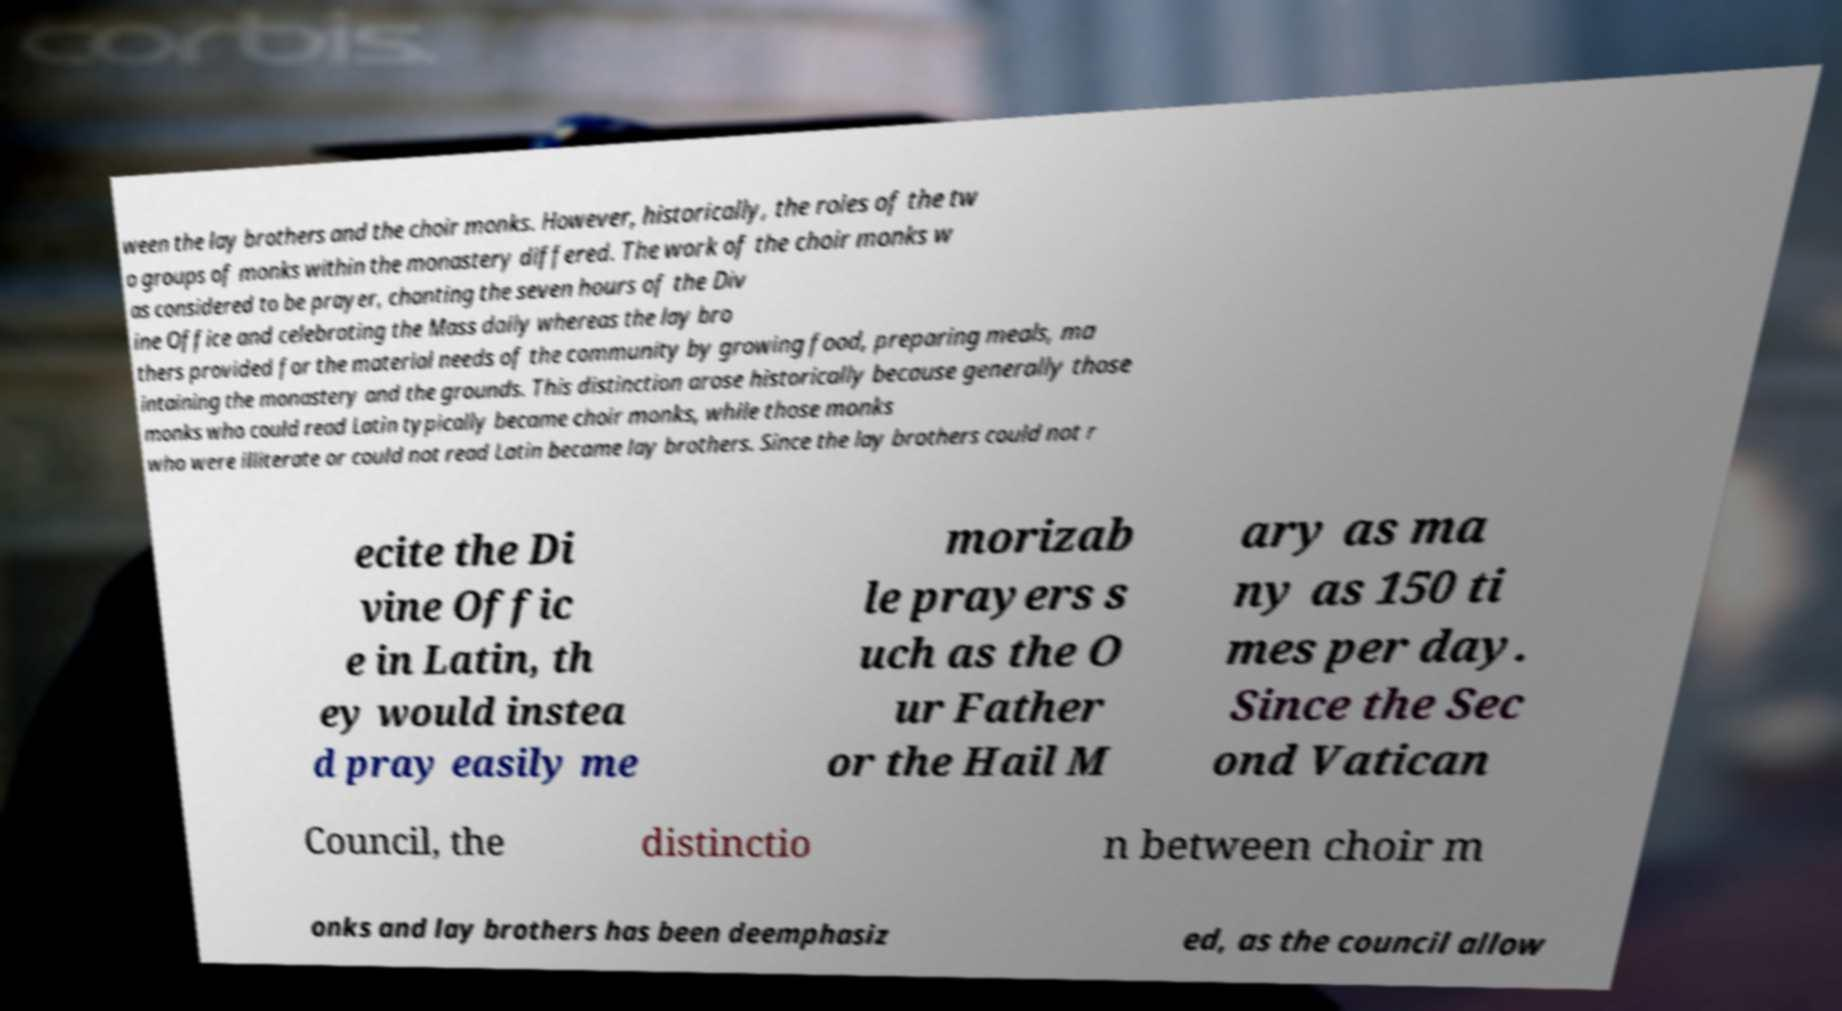Please identify and transcribe the text found in this image. ween the lay brothers and the choir monks. However, historically, the roles of the tw o groups of monks within the monastery differed. The work of the choir monks w as considered to be prayer, chanting the seven hours of the Div ine Office and celebrating the Mass daily whereas the lay bro thers provided for the material needs of the community by growing food, preparing meals, ma intaining the monastery and the grounds. This distinction arose historically because generally those monks who could read Latin typically became choir monks, while those monks who were illiterate or could not read Latin became lay brothers. Since the lay brothers could not r ecite the Di vine Offic e in Latin, th ey would instea d pray easily me morizab le prayers s uch as the O ur Father or the Hail M ary as ma ny as 150 ti mes per day. Since the Sec ond Vatican Council, the distinctio n between choir m onks and lay brothers has been deemphasiz ed, as the council allow 